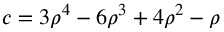Convert formula to latex. <formula><loc_0><loc_0><loc_500><loc_500>c = 3 \rho ^ { 4 } - 6 \rho ^ { 3 } + 4 \rho ^ { 2 } - \rho</formula> 